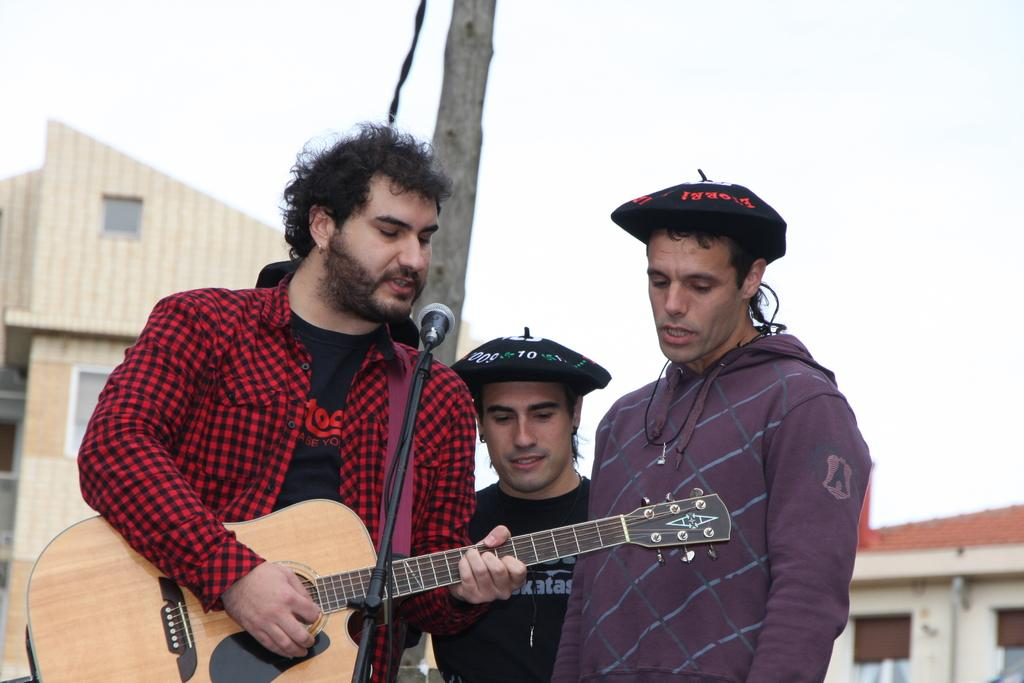How many people are in the image? There are three men in the image. What are the men doing in the image? The men are standing in front of a mic. What instrument is one of the men holding? One man is holding a guitar. What can be seen in the background of the image? There are two houses and a wooden pole in the background of the image. What type of flame can be seen on the guitar in the image? There is no flame present on the guitar in the image. What direction are the men sailing in the image? There is no sailing or boat in the image; it features three men standing in front of a mic. 